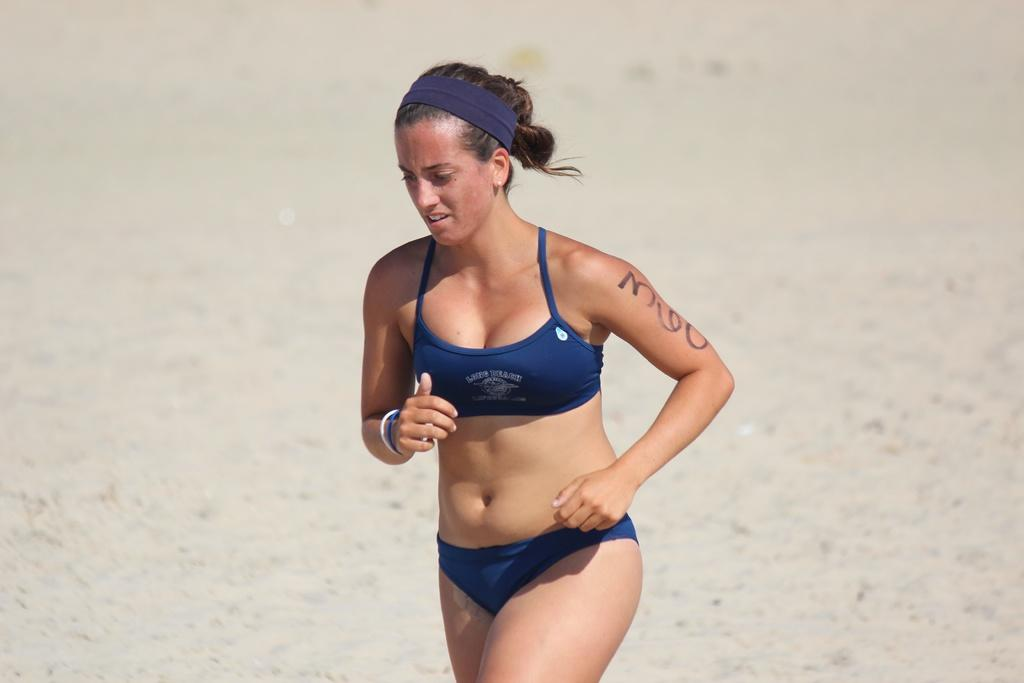What is present in the image? There is a woman in the image. What is the woman doing in the image? The woman is running. What type of car is the woman exchanging in the image? There is no car present in the image, and the woman is not exchanging anything. 